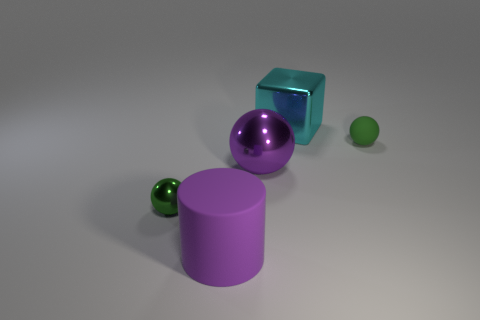There is a large thing that is the same color as the big metal ball; what material is it?
Provide a succinct answer. Rubber. Do the rubber cylinder and the cube have the same size?
Make the answer very short. Yes. What number of objects are either shiny spheres or spheres behind the green metallic sphere?
Make the answer very short. 3. There is a green ball that is the same size as the green metal object; what material is it?
Keep it short and to the point. Rubber. There is a large thing that is both in front of the tiny matte sphere and behind the green metal sphere; what material is it made of?
Your answer should be very brief. Metal. Is there a matte thing on the right side of the large thing behind the green matte object?
Keep it short and to the point. Yes. What size is the metal object that is both in front of the small green rubber object and right of the purple matte object?
Make the answer very short. Large. How many cyan things are small metallic things or matte balls?
Provide a succinct answer. 0. What shape is the cyan thing that is the same size as the purple rubber object?
Your answer should be compact. Cube. What number of other objects are there of the same color as the big cylinder?
Offer a very short reply. 1. 